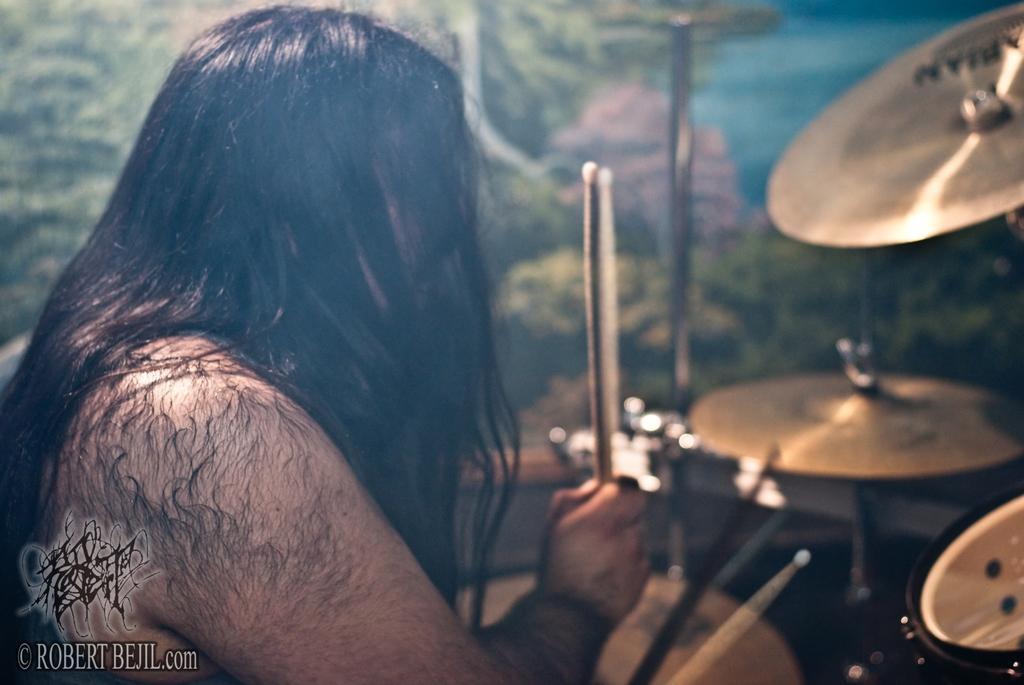Describe this image in one or two sentences. This picture shows a man playing drums with sticks in his hands and we see watermark at the bottom left corner and we see a frame on the wall. 